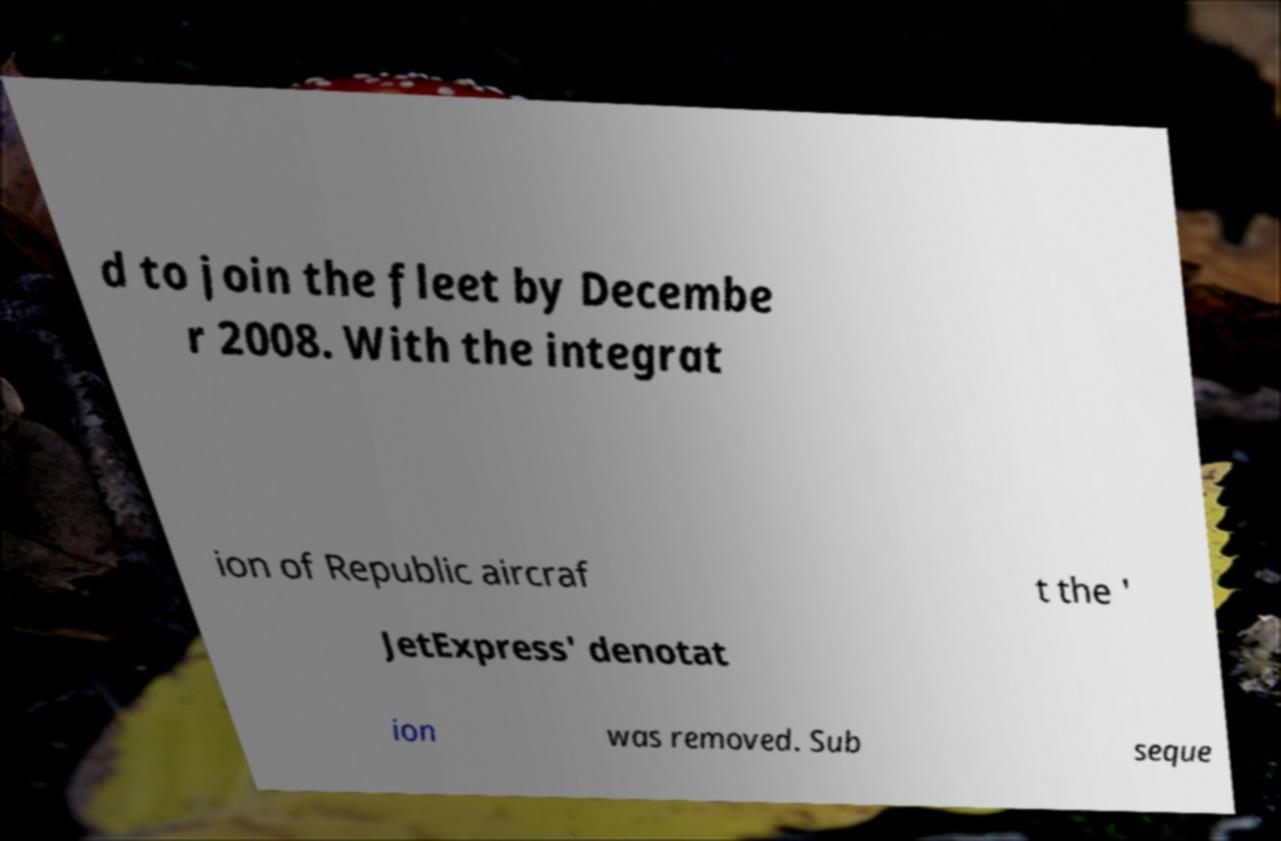Please read and relay the text visible in this image. What does it say? d to join the fleet by Decembe r 2008. With the integrat ion of Republic aircraf t the ' JetExpress' denotat ion was removed. Sub seque 